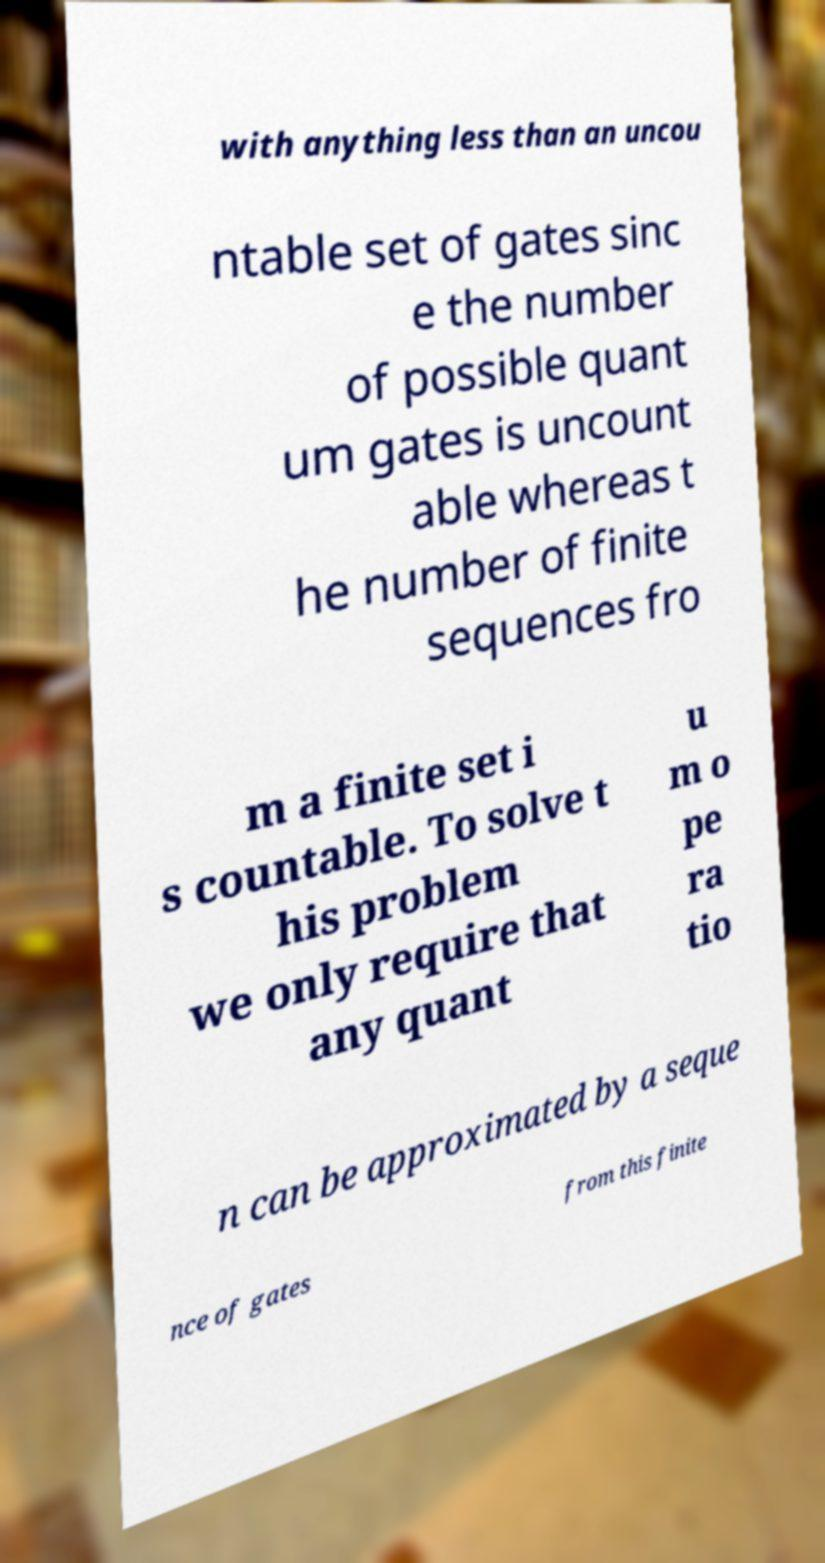Please read and relay the text visible in this image. What does it say? with anything less than an uncou ntable set of gates sinc e the number of possible quant um gates is uncount able whereas t he number of finite sequences fro m a finite set i s countable. To solve t his problem we only require that any quant u m o pe ra tio n can be approximated by a seque nce of gates from this finite 